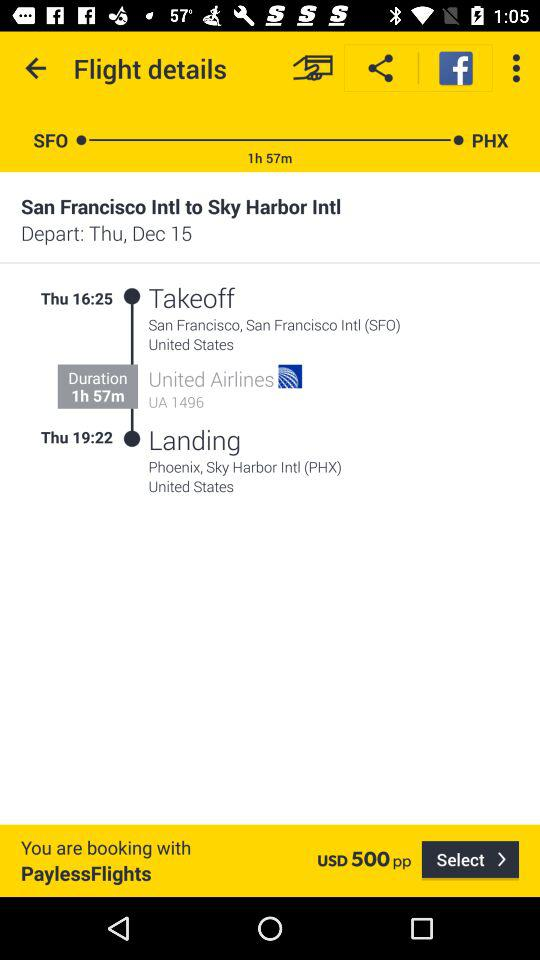From which location will the flight takeoff? The flight will takeoff from San Francisco, San Francisco Intl (SFO), United States. 